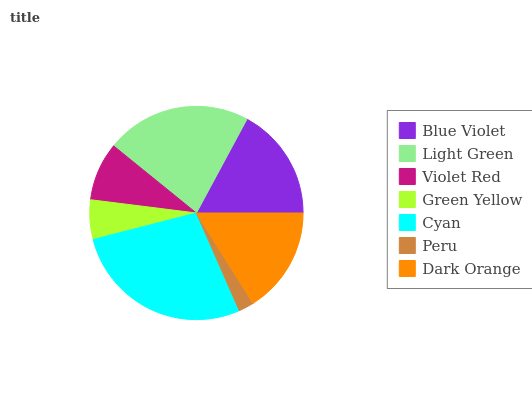Is Peru the minimum?
Answer yes or no. Yes. Is Cyan the maximum?
Answer yes or no. Yes. Is Light Green the minimum?
Answer yes or no. No. Is Light Green the maximum?
Answer yes or no. No. Is Light Green greater than Blue Violet?
Answer yes or no. Yes. Is Blue Violet less than Light Green?
Answer yes or no. Yes. Is Blue Violet greater than Light Green?
Answer yes or no. No. Is Light Green less than Blue Violet?
Answer yes or no. No. Is Dark Orange the high median?
Answer yes or no. Yes. Is Dark Orange the low median?
Answer yes or no. Yes. Is Cyan the high median?
Answer yes or no. No. Is Light Green the low median?
Answer yes or no. No. 